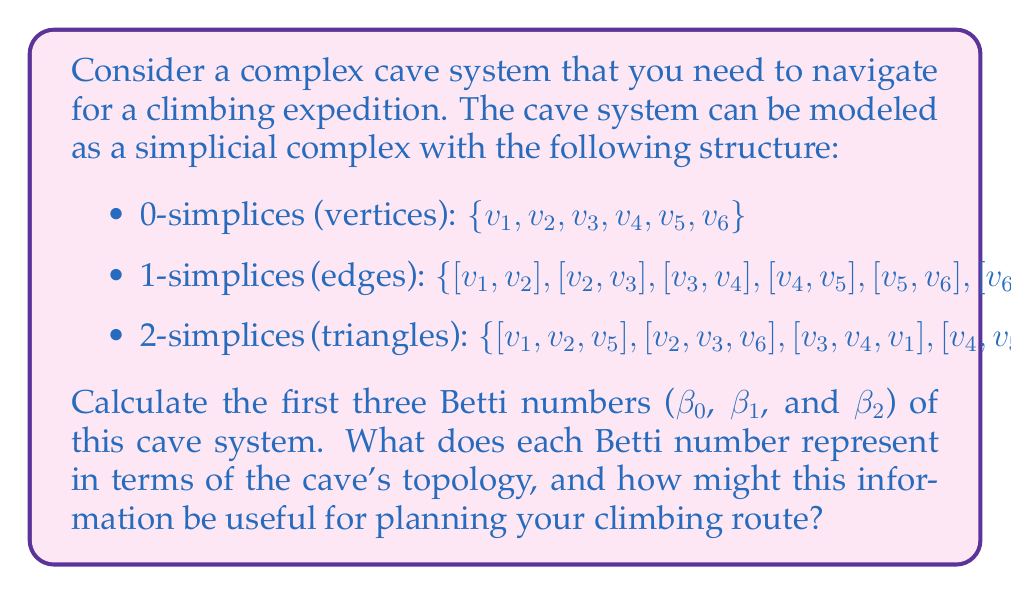Teach me how to tackle this problem. To solve this problem, we need to calculate the Betti numbers using the concept of simplicial homology. Let's go through the steps:

1. First, let's count the number of simplices in each dimension:
   - 0-simplices: 6
   - 1-simplices: 9
   - 2-simplices: 4

2. Now, we need to calculate the ranks of the boundary maps:
   - $\partial_2: C_2 \to C_1$ (2-simplices to 1-simplices)
   - $\partial_1: C_1 \to C_0$ (1-simplices to 0-simplices)

3. To find the rank of $\partial_2$, we need to check the linear independence of the boundary chains of the 2-simplices. After analysis, we find that rank($\partial_2$) = 3.

4. For $\partial_1$, we need to check if the 1-simplices form a connected graph. They do, so rank($\partial_1$) = 5 (number of vertices - 1).

5. Now we can calculate the Betti numbers using the formula:
   $$\beta_k = \dim(\ker \partial_k) - \text{rank}(\partial_{k+1})$$

   For $\beta_0$:
   $\beta_0 = \dim(C_0) - \text{rank}(\partial_1) = 6 - 5 = 1$

   For $\beta_1$:
   $\beta_1 = \dim(\ker \partial_1) - \text{rank}(\partial_2)$
   $= (\dim(C_1) - \text{rank}(\partial_1)) - \text{rank}(\partial_2)$
   $= (9 - 5) - 3 = 1$

   For $\beta_2$:
   $\beta_2 = \dim(\ker \partial_2) = \dim(C_2) - \text{rank}(\partial_2) = 4 - 3 = 1$

6. Interpretation of Betti numbers:
   - $\beta_0 = 1$: This represents the number of connected components. The cave system is connected.
   - $\beta_1 = 1$: This represents the number of 1-dimensional holes or tunnels in the cave system.
   - $\beta_2 = 1$: This represents the number of 2-dimensional voids or cavities in the cave system.

This information is useful for planning a climbing route because:
- The connectedness ($\beta_0 = 1$) ensures that all parts of the cave are accessible.
- The presence of a tunnel ($\beta_1 = 1$) indicates an alternative path or loop in the system.
- The cavity ($\beta_2 = 1$) suggests a large open space within the cave, which could be challenging or interesting for climbing.
Answer: The Betti numbers are:
$\beta_0 = 1$, $\beta_1 = 1$, $\beta_2 = 1$

These numbers indicate that the cave system is connected, has one tunnel or loop, and contains one large cavity or chamber. 